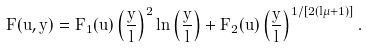<formula> <loc_0><loc_0><loc_500><loc_500>F ( u , y ) = F _ { 1 } ( u ) \left ( \frac { y } l \right ) ^ { 2 } \ln \left ( \frac { y } l \right ) + F _ { 2 } ( u ) \left ( \frac { y } l \right ) ^ { 1 / [ 2 ( l \mu + 1 ) ] } .</formula> 